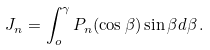Convert formula to latex. <formula><loc_0><loc_0><loc_500><loc_500>J _ { n } = \int ^ { \gamma } _ { o } P _ { n } ( \cos \beta ) \sin \beta d \beta \, .</formula> 